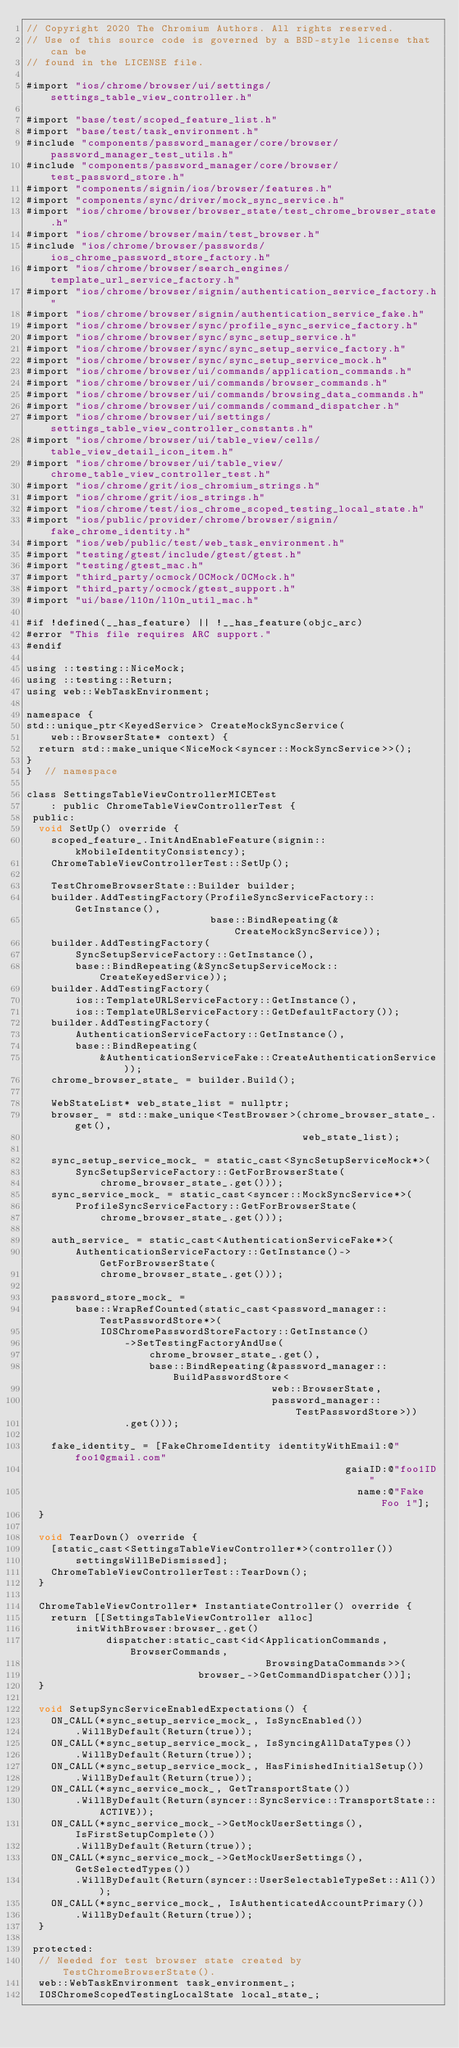<code> <loc_0><loc_0><loc_500><loc_500><_ObjectiveC_>// Copyright 2020 The Chromium Authors. All rights reserved.
// Use of this source code is governed by a BSD-style license that can be
// found in the LICENSE file.

#import "ios/chrome/browser/ui/settings/settings_table_view_controller.h"

#import "base/test/scoped_feature_list.h"
#import "base/test/task_environment.h"
#include "components/password_manager/core/browser/password_manager_test_utils.h"
#include "components/password_manager/core/browser/test_password_store.h"
#import "components/signin/ios/browser/features.h"
#import "components/sync/driver/mock_sync_service.h"
#import "ios/chrome/browser/browser_state/test_chrome_browser_state.h"
#import "ios/chrome/browser/main/test_browser.h"
#include "ios/chrome/browser/passwords/ios_chrome_password_store_factory.h"
#import "ios/chrome/browser/search_engines/template_url_service_factory.h"
#import "ios/chrome/browser/signin/authentication_service_factory.h"
#import "ios/chrome/browser/signin/authentication_service_fake.h"
#import "ios/chrome/browser/sync/profile_sync_service_factory.h"
#import "ios/chrome/browser/sync/sync_setup_service.h"
#import "ios/chrome/browser/sync/sync_setup_service_factory.h"
#import "ios/chrome/browser/sync/sync_setup_service_mock.h"
#import "ios/chrome/browser/ui/commands/application_commands.h"
#import "ios/chrome/browser/ui/commands/browser_commands.h"
#import "ios/chrome/browser/ui/commands/browsing_data_commands.h"
#import "ios/chrome/browser/ui/commands/command_dispatcher.h"
#import "ios/chrome/browser/ui/settings/settings_table_view_controller_constants.h"
#import "ios/chrome/browser/ui/table_view/cells/table_view_detail_icon_item.h"
#import "ios/chrome/browser/ui/table_view/chrome_table_view_controller_test.h"
#import "ios/chrome/grit/ios_chromium_strings.h"
#import "ios/chrome/grit/ios_strings.h"
#import "ios/chrome/test/ios_chrome_scoped_testing_local_state.h"
#import "ios/public/provider/chrome/browser/signin/fake_chrome_identity.h"
#import "ios/web/public/test/web_task_environment.h"
#import "testing/gtest/include/gtest/gtest.h"
#import "testing/gtest_mac.h"
#import "third_party/ocmock/OCMock/OCMock.h"
#import "third_party/ocmock/gtest_support.h"
#import "ui/base/l10n/l10n_util_mac.h"

#if !defined(__has_feature) || !__has_feature(objc_arc)
#error "This file requires ARC support."
#endif

using ::testing::NiceMock;
using ::testing::Return;
using web::WebTaskEnvironment;

namespace {
std::unique_ptr<KeyedService> CreateMockSyncService(
    web::BrowserState* context) {
  return std::make_unique<NiceMock<syncer::MockSyncService>>();
}
}  // namespace

class SettingsTableViewControllerMICETest
    : public ChromeTableViewControllerTest {
 public:
  void SetUp() override {
    scoped_feature_.InitAndEnableFeature(signin::kMobileIdentityConsistency);
    ChromeTableViewControllerTest::SetUp();

    TestChromeBrowserState::Builder builder;
    builder.AddTestingFactory(ProfileSyncServiceFactory::GetInstance(),
                              base::BindRepeating(&CreateMockSyncService));
    builder.AddTestingFactory(
        SyncSetupServiceFactory::GetInstance(),
        base::BindRepeating(&SyncSetupServiceMock::CreateKeyedService));
    builder.AddTestingFactory(
        ios::TemplateURLServiceFactory::GetInstance(),
        ios::TemplateURLServiceFactory::GetDefaultFactory());
    builder.AddTestingFactory(
        AuthenticationServiceFactory::GetInstance(),
        base::BindRepeating(
            &AuthenticationServiceFake::CreateAuthenticationService));
    chrome_browser_state_ = builder.Build();

    WebStateList* web_state_list = nullptr;
    browser_ = std::make_unique<TestBrowser>(chrome_browser_state_.get(),
                                             web_state_list);

    sync_setup_service_mock_ = static_cast<SyncSetupServiceMock*>(
        SyncSetupServiceFactory::GetForBrowserState(
            chrome_browser_state_.get()));
    sync_service_mock_ = static_cast<syncer::MockSyncService*>(
        ProfileSyncServiceFactory::GetForBrowserState(
            chrome_browser_state_.get()));

    auth_service_ = static_cast<AuthenticationServiceFake*>(
        AuthenticationServiceFactory::GetInstance()->GetForBrowserState(
            chrome_browser_state_.get()));

    password_store_mock_ =
        base::WrapRefCounted(static_cast<password_manager::TestPasswordStore*>(
            IOSChromePasswordStoreFactory::GetInstance()
                ->SetTestingFactoryAndUse(
                    chrome_browser_state_.get(),
                    base::BindRepeating(&password_manager::BuildPasswordStore<
                                        web::BrowserState,
                                        password_manager::TestPasswordStore>))
                .get()));

    fake_identity_ = [FakeChromeIdentity identityWithEmail:@"foo1@gmail.com"
                                                    gaiaID:@"foo1ID"
                                                      name:@"Fake Foo 1"];
  }

  void TearDown() override {
    [static_cast<SettingsTableViewController*>(controller())
        settingsWillBeDismissed];
    ChromeTableViewControllerTest::TearDown();
  }

  ChromeTableViewController* InstantiateController() override {
    return [[SettingsTableViewController alloc]
        initWithBrowser:browser_.get()
             dispatcher:static_cast<id<ApplicationCommands, BrowserCommands,
                                       BrowsingDataCommands>>(
                            browser_->GetCommandDispatcher())];
  }

  void SetupSyncServiceEnabledExpectations() {
    ON_CALL(*sync_setup_service_mock_, IsSyncEnabled())
        .WillByDefault(Return(true));
    ON_CALL(*sync_setup_service_mock_, IsSyncingAllDataTypes())
        .WillByDefault(Return(true));
    ON_CALL(*sync_setup_service_mock_, HasFinishedInitialSetup())
        .WillByDefault(Return(true));
    ON_CALL(*sync_service_mock_, GetTransportState())
        .WillByDefault(Return(syncer::SyncService::TransportState::ACTIVE));
    ON_CALL(*sync_service_mock_->GetMockUserSettings(), IsFirstSetupComplete())
        .WillByDefault(Return(true));
    ON_CALL(*sync_service_mock_->GetMockUserSettings(), GetSelectedTypes())
        .WillByDefault(Return(syncer::UserSelectableTypeSet::All()));
    ON_CALL(*sync_service_mock_, IsAuthenticatedAccountPrimary())
        .WillByDefault(Return(true));
  }

 protected:
  // Needed for test browser state created by TestChromeBrowserState().
  web::WebTaskEnvironment task_environment_;
  IOSChromeScopedTestingLocalState local_state_;</code> 